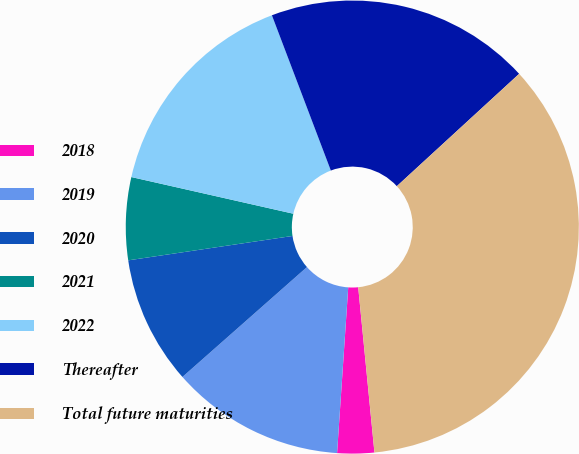Convert chart to OTSL. <chart><loc_0><loc_0><loc_500><loc_500><pie_chart><fcel>2018<fcel>2019<fcel>2020<fcel>2021<fcel>2022<fcel>Thereafter<fcel>Total future maturities<nl><fcel>2.63%<fcel>12.42%<fcel>9.16%<fcel>5.89%<fcel>15.68%<fcel>18.95%<fcel>35.26%<nl></chart> 